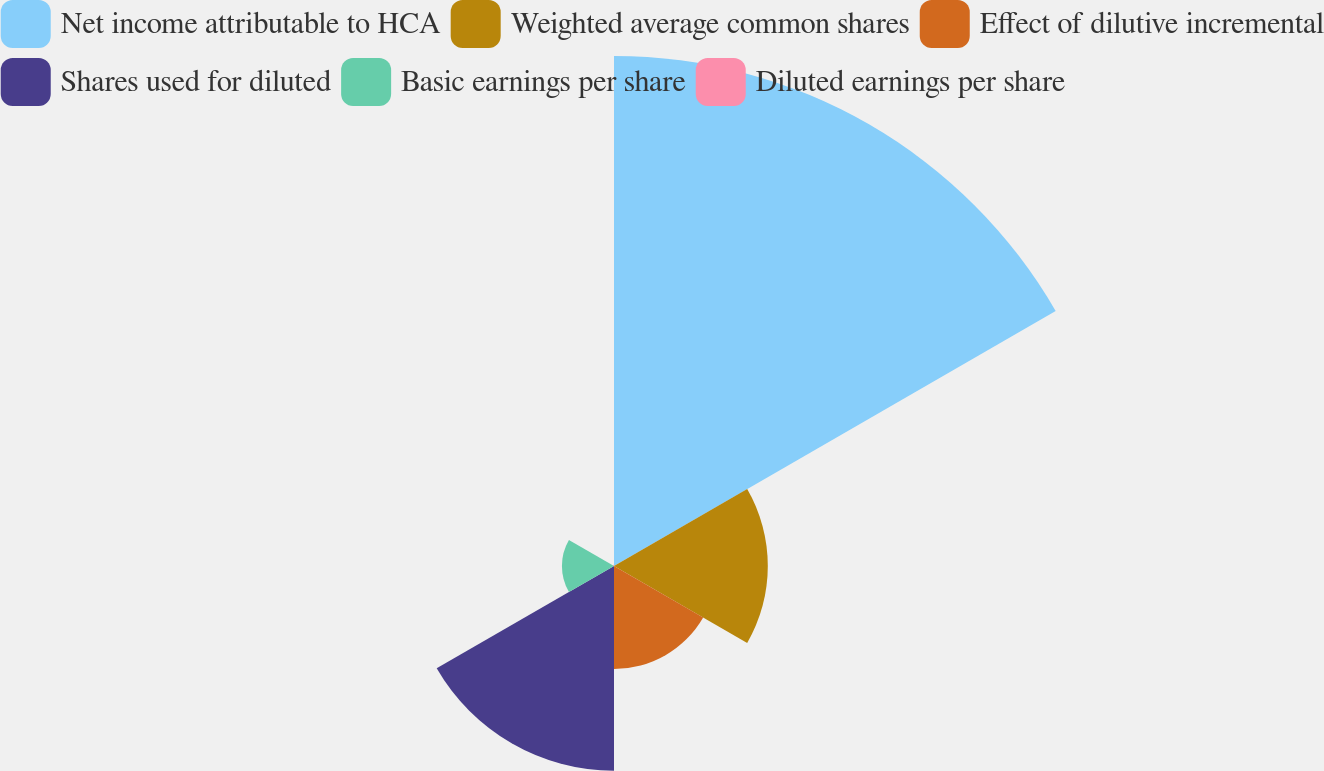<chart> <loc_0><loc_0><loc_500><loc_500><pie_chart><fcel>Net income attributable to HCA<fcel>Weighted average common shares<fcel>Effect of dilutive incremental<fcel>Shares used for diluted<fcel>Basic earnings per share<fcel>Diluted earnings per share<nl><fcel>49.77%<fcel>15.01%<fcel>10.05%<fcel>19.98%<fcel>5.08%<fcel>0.12%<nl></chart> 